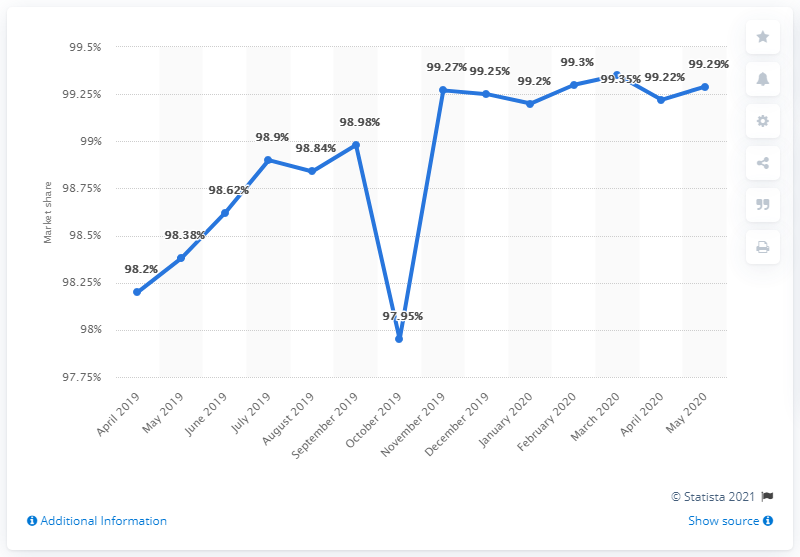Highlight a few significant elements in this photo. In September 2018, the mobile search market in India accounted for 97.95% of all searches performed on mobile devices. As of May 2020, Google's share of the Indian mobile search market was 99.29%. 